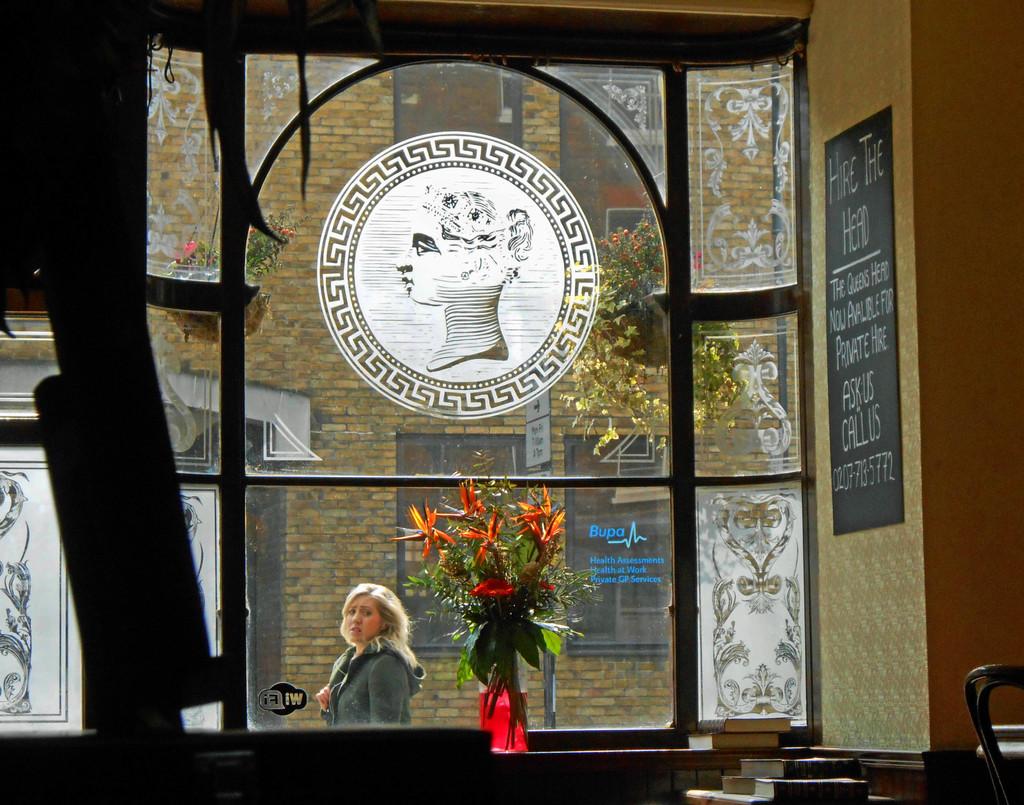Does this establishment offer wifi to its guests?
Keep it short and to the point. Yes. What is the number on the bottom of the sign?
Give a very brief answer. 0207-713-5772. 